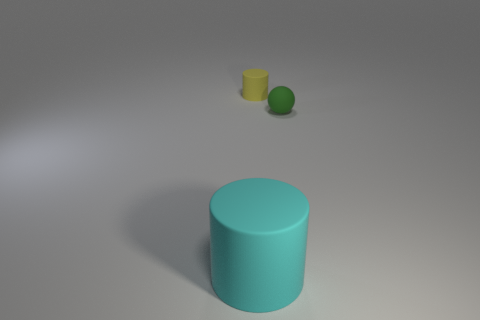Add 1 gray matte objects. How many objects exist? 4 Subtract all spheres. How many objects are left? 2 Add 2 green things. How many green things exist? 3 Subtract 0 blue cubes. How many objects are left? 3 Subtract all tiny cyan shiny spheres. Subtract all small yellow rubber things. How many objects are left? 2 Add 1 cyan rubber cylinders. How many cyan rubber cylinders are left? 2 